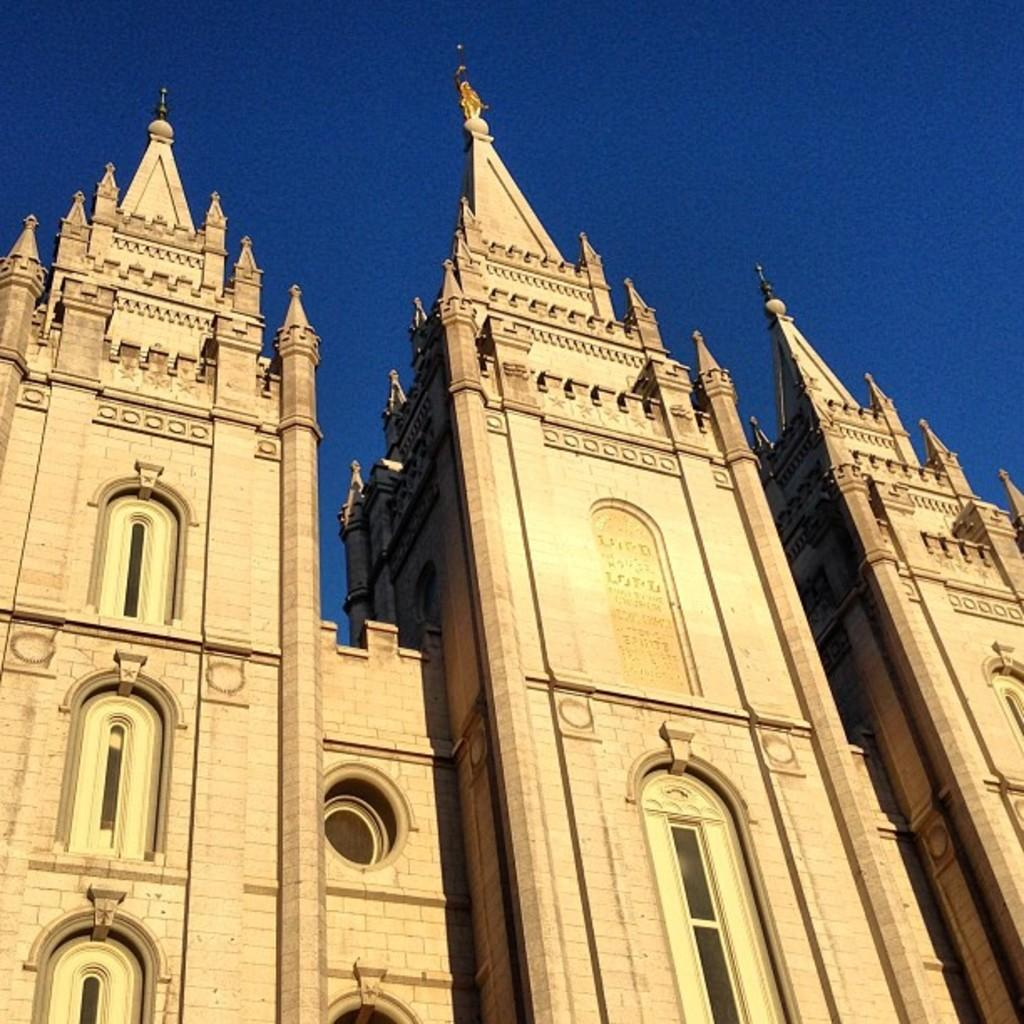What type of structures are present in the image? There are buildings in the image. What color are the buildings? The buildings are brown in color. What can be seen in the background of the image? There is a blue sky visible in the background of the image. How many pairs of shoes are hanging from the buildings in the image? There are no shoes visible in the image; it only features buildings and a blue sky. 